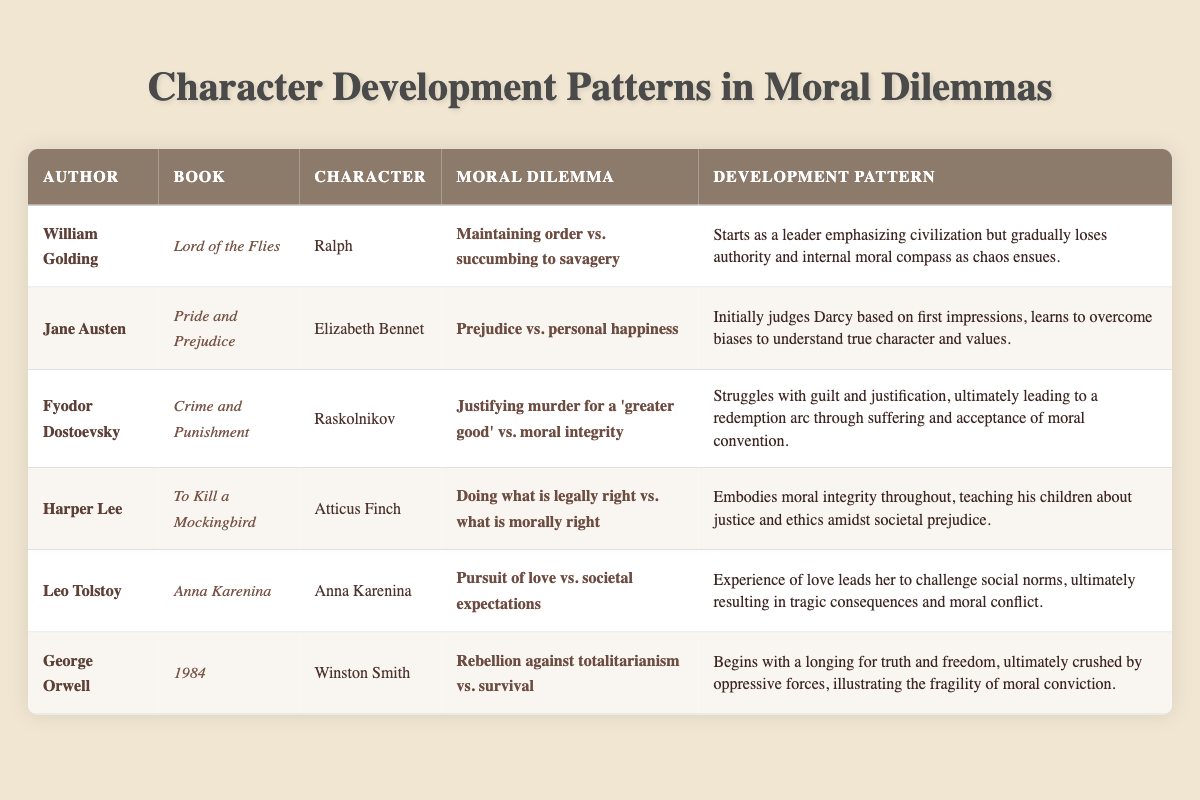What moral dilemma does Ralph face in "Lord of the Flies"? The table indicates that Ralph's moral dilemma is maintaining order versus succumbing to savagery. This information is obtained directly from the corresponding row in the table.
Answer: Maintaining order vs. succumbing to savagery How does Elizabeth Bennet's character development pattern manifest in "Pride and Prejudice"? According to the table, Elizabeth Bennet starts by judging Darcy based on his first impression but learns to overcome her biases to understand his true character. This development is explicitly outlined in her respective row.
Answer: Learns to overcome biases to understand true character and values Is Atticus Finch's moral dilemma based on legality or morality? The table states that Atticus Finch's dilemma involves doing what is legally right versus what is morally right. This can be confirmed by examining the row dedicated to Atticus Finch.
Answer: Yes Which author's character experiences a redemption arc through suffering? The data shows that Raskolnikov from "Crime and Punishment" undergoes a redemption arc through suffering, according to the development pattern described in the table. Verification requires identifying Raskolnikov's row and noting his experiences.
Answer: Fyodor Dostoevsky Count the number of characters associated with a moral dilemma related to societal expectations. The table highlights two characters facing dilemmas linked to societal expectations: Anna Karenina and Atticus Finch. Counting the relevant rows yields a total of two characters who grapple with these social pressures.
Answer: 2 What contrasting themes can be identified from the moral dilemmas of "To Kill a Mockingbird" and "1984"? The table reveals that Atticus Finch's dilemma pertains to legal versus moral right, while Winston Smith's dilemma revolves around rebellion against totalitarianism versus survival. These contrasting themes can be analyzed to uncover differing perspectives on moral decision-making in oppressive versus societal contexts.
Answer: Legal/moral right vs. rebellion/survival Does Anna Karenina's development pattern suggest a positive or negative outcome? Analyzing the data from the table, Anna Karenina's pursuit of love leads to tragic consequences and moral conflict. This indicates that her character development pattern culminates in a negative outcome. Therefore, the answer is negative.
Answer: Negative 